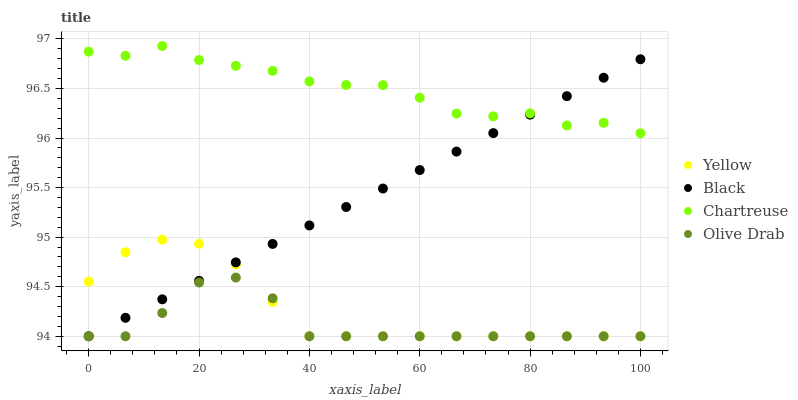Does Olive Drab have the minimum area under the curve?
Answer yes or no. Yes. Does Chartreuse have the maximum area under the curve?
Answer yes or no. Yes. Does Black have the minimum area under the curve?
Answer yes or no. No. Does Black have the maximum area under the curve?
Answer yes or no. No. Is Black the smoothest?
Answer yes or no. Yes. Is Chartreuse the roughest?
Answer yes or no. Yes. Is Olive Drab the smoothest?
Answer yes or no. No. Is Olive Drab the roughest?
Answer yes or no. No. Does Black have the lowest value?
Answer yes or no. Yes. Does Chartreuse have the highest value?
Answer yes or no. Yes. Does Black have the highest value?
Answer yes or no. No. Is Yellow less than Chartreuse?
Answer yes or no. Yes. Is Chartreuse greater than Yellow?
Answer yes or no. Yes. Does Olive Drab intersect Black?
Answer yes or no. Yes. Is Olive Drab less than Black?
Answer yes or no. No. Is Olive Drab greater than Black?
Answer yes or no. No. Does Yellow intersect Chartreuse?
Answer yes or no. No. 